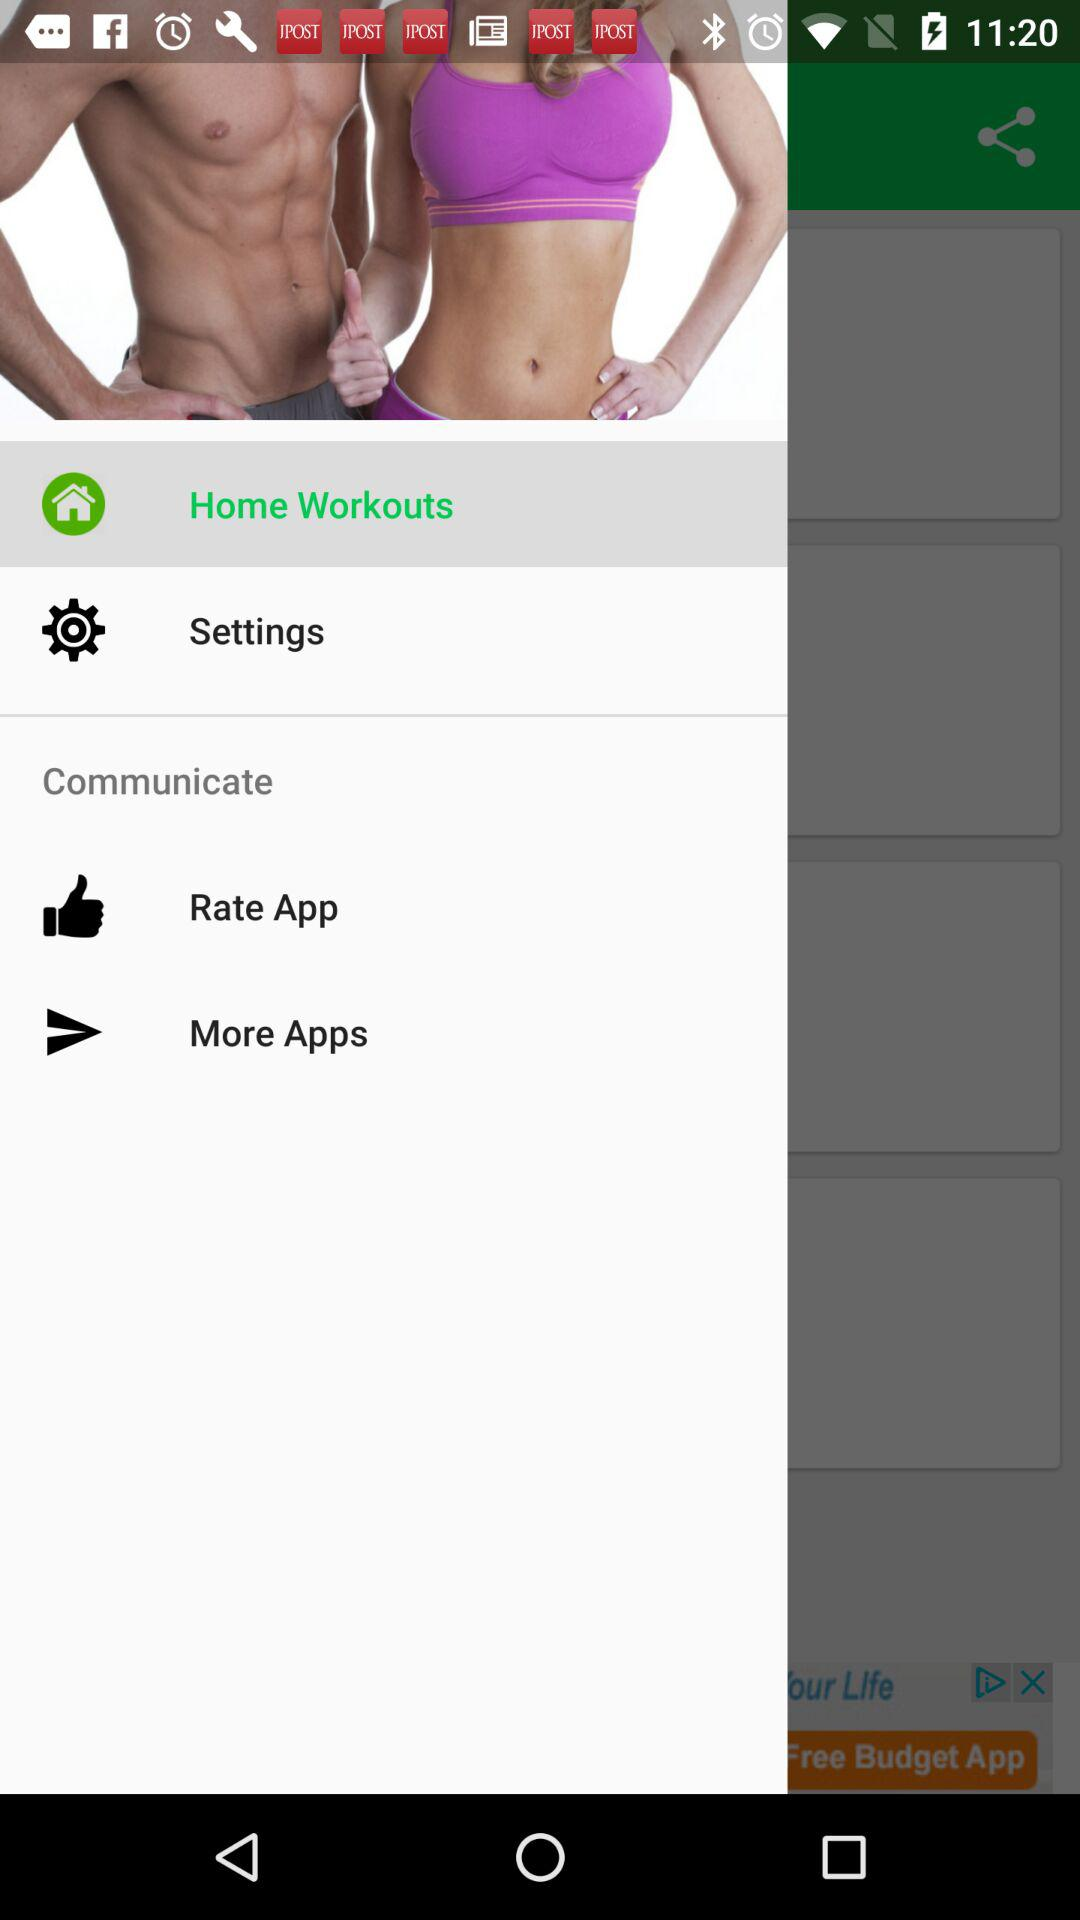Which item is selected? The selected item is "Home Workouts". 